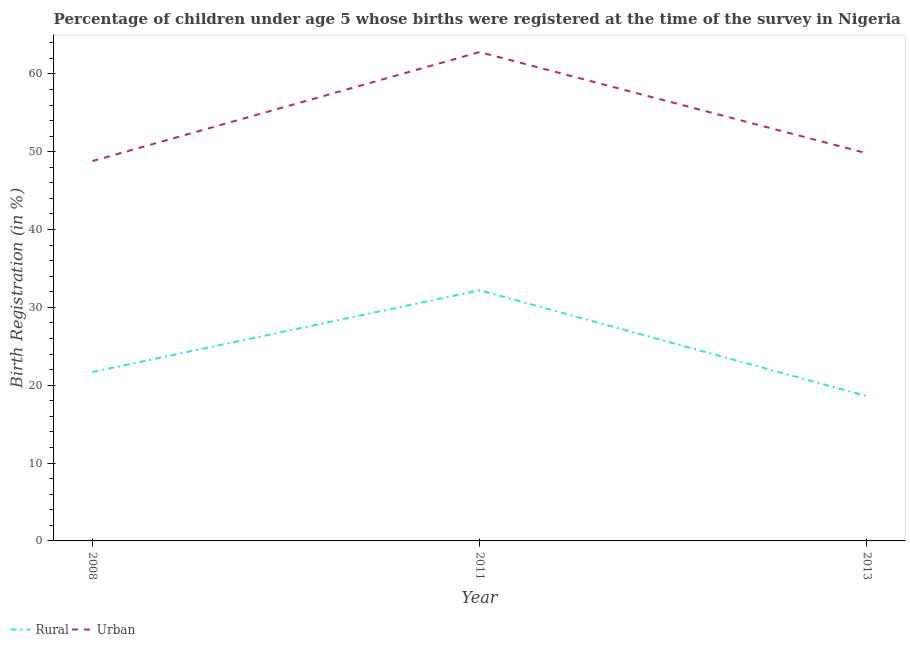Is the number of lines equal to the number of legend labels?
Make the answer very short. Yes. What is the rural birth registration in 2013?
Your response must be concise. 18.6. Across all years, what is the maximum rural birth registration?
Ensure brevity in your answer.  32.2. Across all years, what is the minimum urban birth registration?
Provide a succinct answer. 48.8. What is the total urban birth registration in the graph?
Provide a short and direct response. 161.4. What is the difference between the rural birth registration in 2013 and the urban birth registration in 2011?
Your answer should be very brief. -44.2. What is the average rural birth registration per year?
Offer a terse response. 24.17. In the year 2013, what is the difference between the rural birth registration and urban birth registration?
Ensure brevity in your answer.  -31.2. In how many years, is the urban birth registration greater than 24 %?
Provide a succinct answer. 3. What is the ratio of the rural birth registration in 2008 to that in 2013?
Keep it short and to the point. 1.17. Is the urban birth registration in 2008 less than that in 2013?
Offer a terse response. Yes. Is the difference between the urban birth registration in 2008 and 2013 greater than the difference between the rural birth registration in 2008 and 2013?
Keep it short and to the point. No. What is the difference between the highest and the second highest rural birth registration?
Give a very brief answer. 10.5. What is the difference between the highest and the lowest urban birth registration?
Your answer should be compact. 14. Is the sum of the rural birth registration in 2008 and 2011 greater than the maximum urban birth registration across all years?
Provide a succinct answer. No. Does the urban birth registration monotonically increase over the years?
Offer a very short reply. No. Is the urban birth registration strictly greater than the rural birth registration over the years?
Make the answer very short. Yes. How many lines are there?
Provide a succinct answer. 2. How many years are there in the graph?
Your answer should be very brief. 3. What is the difference between two consecutive major ticks on the Y-axis?
Your response must be concise. 10. Does the graph contain any zero values?
Your answer should be very brief. No. Where does the legend appear in the graph?
Your answer should be compact. Bottom left. How many legend labels are there?
Offer a terse response. 2. What is the title of the graph?
Your response must be concise. Percentage of children under age 5 whose births were registered at the time of the survey in Nigeria. Does "Female" appear as one of the legend labels in the graph?
Make the answer very short. No. What is the label or title of the Y-axis?
Give a very brief answer. Birth Registration (in %). What is the Birth Registration (in %) of Rural in 2008?
Ensure brevity in your answer.  21.7. What is the Birth Registration (in %) in Urban in 2008?
Provide a succinct answer. 48.8. What is the Birth Registration (in %) of Rural in 2011?
Offer a terse response. 32.2. What is the Birth Registration (in %) in Urban in 2011?
Your response must be concise. 62.8. What is the Birth Registration (in %) in Urban in 2013?
Provide a short and direct response. 49.8. Across all years, what is the maximum Birth Registration (in %) in Rural?
Your answer should be compact. 32.2. Across all years, what is the maximum Birth Registration (in %) of Urban?
Provide a succinct answer. 62.8. Across all years, what is the minimum Birth Registration (in %) in Urban?
Keep it short and to the point. 48.8. What is the total Birth Registration (in %) of Rural in the graph?
Your answer should be very brief. 72.5. What is the total Birth Registration (in %) of Urban in the graph?
Provide a short and direct response. 161.4. What is the difference between the Birth Registration (in %) of Urban in 2008 and that in 2013?
Offer a very short reply. -1. What is the difference between the Birth Registration (in %) of Rural in 2008 and the Birth Registration (in %) of Urban in 2011?
Make the answer very short. -41.1. What is the difference between the Birth Registration (in %) of Rural in 2008 and the Birth Registration (in %) of Urban in 2013?
Your answer should be very brief. -28.1. What is the difference between the Birth Registration (in %) in Rural in 2011 and the Birth Registration (in %) in Urban in 2013?
Ensure brevity in your answer.  -17.6. What is the average Birth Registration (in %) of Rural per year?
Provide a succinct answer. 24.17. What is the average Birth Registration (in %) of Urban per year?
Your answer should be very brief. 53.8. In the year 2008, what is the difference between the Birth Registration (in %) in Rural and Birth Registration (in %) in Urban?
Your answer should be compact. -27.1. In the year 2011, what is the difference between the Birth Registration (in %) of Rural and Birth Registration (in %) of Urban?
Your response must be concise. -30.6. In the year 2013, what is the difference between the Birth Registration (in %) in Rural and Birth Registration (in %) in Urban?
Your response must be concise. -31.2. What is the ratio of the Birth Registration (in %) in Rural in 2008 to that in 2011?
Offer a terse response. 0.67. What is the ratio of the Birth Registration (in %) in Urban in 2008 to that in 2011?
Your answer should be very brief. 0.78. What is the ratio of the Birth Registration (in %) in Rural in 2008 to that in 2013?
Offer a very short reply. 1.17. What is the ratio of the Birth Registration (in %) of Urban in 2008 to that in 2013?
Offer a terse response. 0.98. What is the ratio of the Birth Registration (in %) in Rural in 2011 to that in 2013?
Offer a very short reply. 1.73. What is the ratio of the Birth Registration (in %) in Urban in 2011 to that in 2013?
Provide a succinct answer. 1.26. What is the difference between the highest and the second highest Birth Registration (in %) of Rural?
Offer a very short reply. 10.5. What is the difference between the highest and the second highest Birth Registration (in %) in Urban?
Ensure brevity in your answer.  13. What is the difference between the highest and the lowest Birth Registration (in %) of Rural?
Your response must be concise. 13.6. What is the difference between the highest and the lowest Birth Registration (in %) in Urban?
Your answer should be compact. 14. 